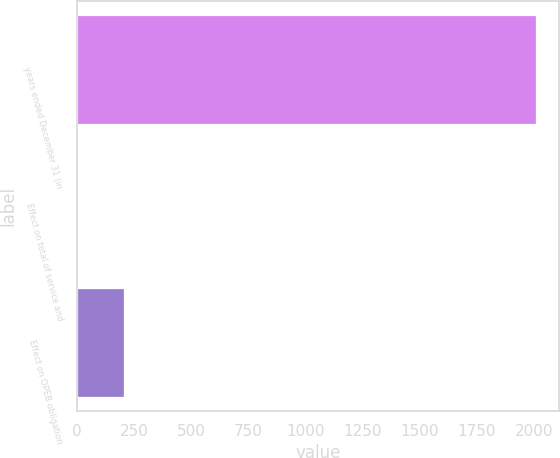Convert chart. <chart><loc_0><loc_0><loc_500><loc_500><bar_chart><fcel>years ended December 31 (in<fcel>Effect on total of service and<fcel>Effect on OPEB obligation<nl><fcel>2012<fcel>5<fcel>205.7<nl></chart> 